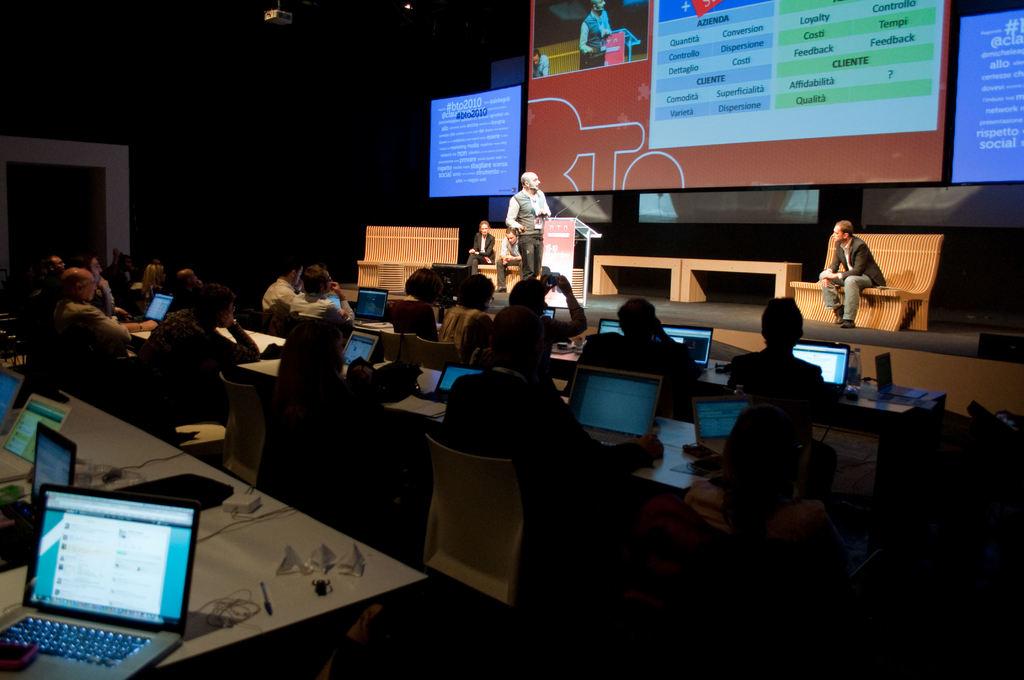Are they showing clientel?
Offer a very short reply. Yes. 